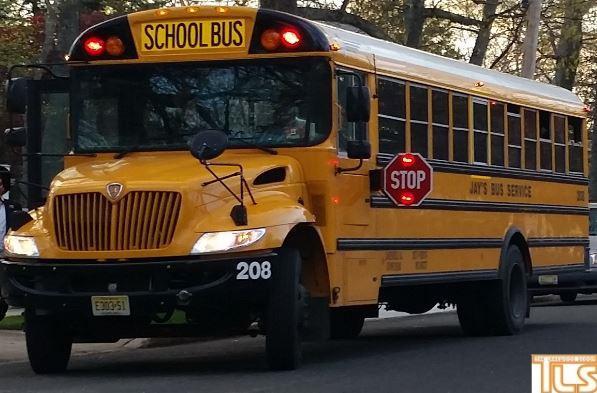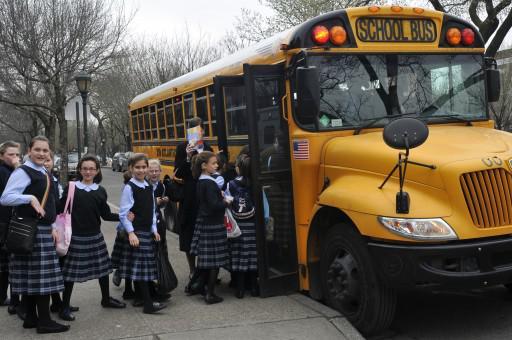The first image is the image on the left, the second image is the image on the right. For the images shown, is this caption "People are standing outside the bus in the image on the right." true? Answer yes or no. Yes. 